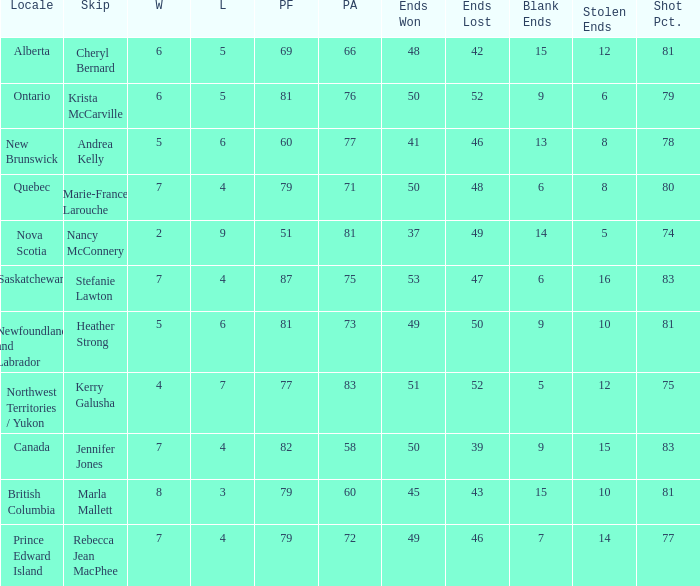Parse the full table. {'header': ['Locale', 'Skip', 'W', 'L', 'PF', 'PA', 'Ends Won', 'Ends Lost', 'Blank Ends', 'Stolen Ends', 'Shot Pct.'], 'rows': [['Alberta', 'Cheryl Bernard', '6', '5', '69', '66', '48', '42', '15', '12', '81'], ['Ontario', 'Krista McCarville', '6', '5', '81', '76', '50', '52', '9', '6', '79'], ['New Brunswick', 'Andrea Kelly', '5', '6', '60', '77', '41', '46', '13', '8', '78'], ['Quebec', 'Marie-France Larouche', '7', '4', '79', '71', '50', '48', '6', '8', '80'], ['Nova Scotia', 'Nancy McConnery', '2', '9', '51', '81', '37', '49', '14', '5', '74'], ['Saskatchewan', 'Stefanie Lawton', '7', '4', '87', '75', '53', '47', '6', '16', '83'], ['Newfoundland and Labrador', 'Heather Strong', '5', '6', '81', '73', '49', '50', '9', '10', '81'], ['Northwest Territories / Yukon', 'Kerry Galusha', '4', '7', '77', '83', '51', '52', '5', '12', '75'], ['Canada', 'Jennifer Jones', '7', '4', '82', '58', '50', '39', '9', '15', '83'], ['British Columbia', 'Marla Mallett', '8', '3', '79', '60', '45', '43', '15', '10', '81'], ['Prince Edward Island', 'Rebecca Jean MacPhee', '7', '4', '79', '72', '49', '46', '7', '14', '77']]} Where was the shot pct 78? New Brunswick. 